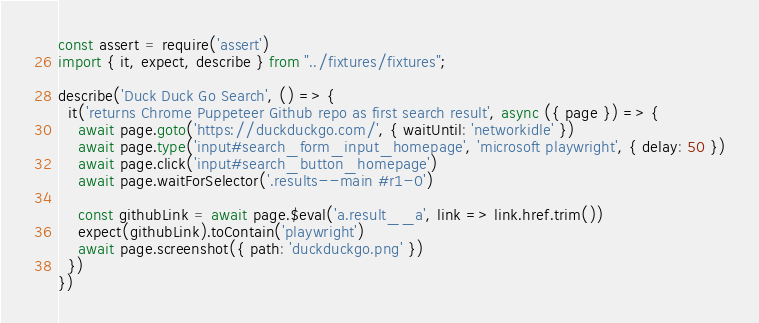Convert code to text. <code><loc_0><loc_0><loc_500><loc_500><_TypeScript_>const assert = require('assert')
import { it, expect, describe } from "../fixtures/fixtures";

describe('Duck Duck Go Search', () => {
  it('returns Chrome Puppeteer Github repo as first search result', async ({ page }) => {
    await page.goto('https://duckduckgo.com/', { waitUntil: 'networkidle' })
    await page.type('input#search_form_input_homepage', 'microsoft playwright', { delay: 50 })
    await page.click('input#search_button_homepage')
    await page.waitForSelector('.results--main #r1-0')

    const githubLink = await page.$eval('a.result__a', link => link.href.trim())
    expect(githubLink).toContain('playwright')
    await page.screenshot({ path: 'duckduckgo.png' })
  })
})</code> 